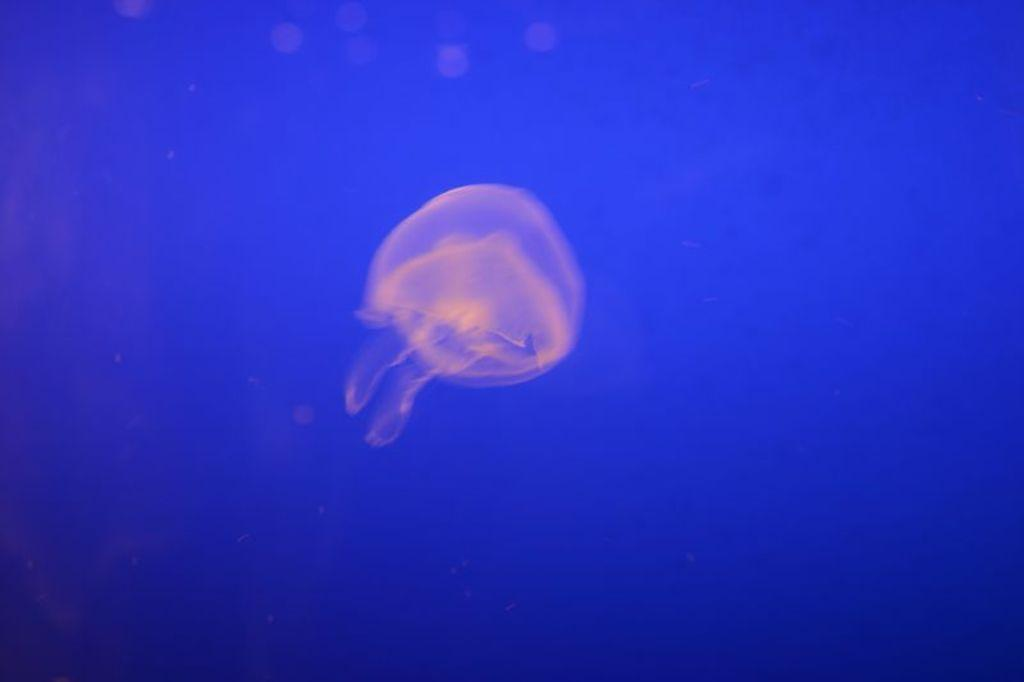What is the main subject of the image? There is a jellyfish in the image. What is the jellyfish doing in the image? The jellyfish is swimming in the water. What type of grape is being served for lunch in the image? There is no lunch or grape present in the image; it features a jellyfish swimming in the water. What is the jellyfish thinking about in the image? The image does not depict the jellyfish's thoughts or emotions, so it is not possible to determine what the jellyfish might be thinking about. 